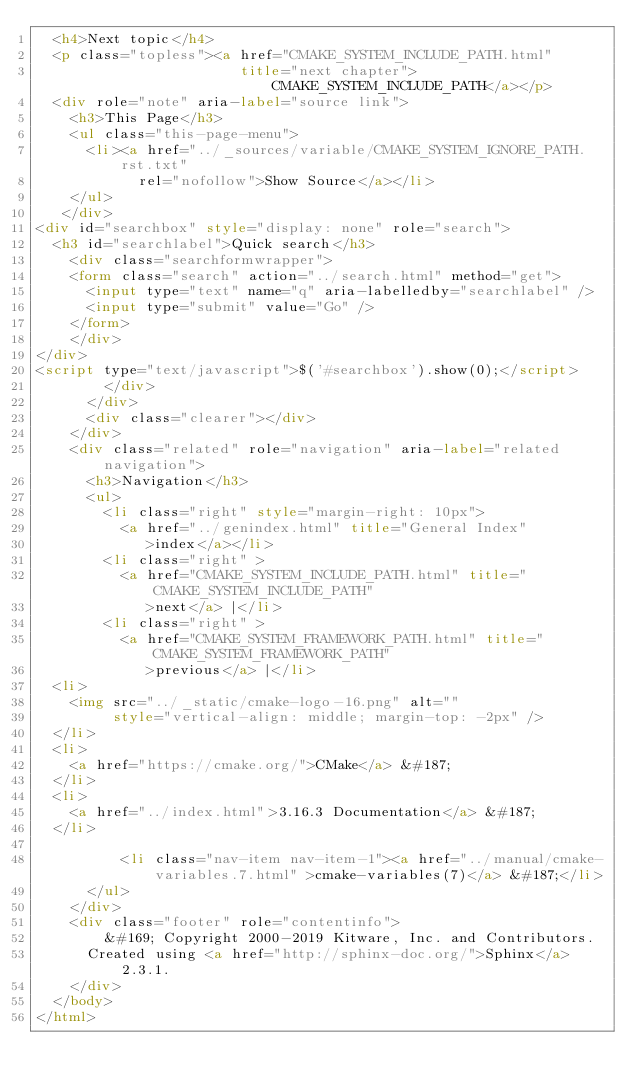<code> <loc_0><loc_0><loc_500><loc_500><_HTML_>  <h4>Next topic</h4>
  <p class="topless"><a href="CMAKE_SYSTEM_INCLUDE_PATH.html"
                        title="next chapter">CMAKE_SYSTEM_INCLUDE_PATH</a></p>
  <div role="note" aria-label="source link">
    <h3>This Page</h3>
    <ul class="this-page-menu">
      <li><a href="../_sources/variable/CMAKE_SYSTEM_IGNORE_PATH.rst.txt"
            rel="nofollow">Show Source</a></li>
    </ul>
   </div>
<div id="searchbox" style="display: none" role="search">
  <h3 id="searchlabel">Quick search</h3>
    <div class="searchformwrapper">
    <form class="search" action="../search.html" method="get">
      <input type="text" name="q" aria-labelledby="searchlabel" />
      <input type="submit" value="Go" />
    </form>
    </div>
</div>
<script type="text/javascript">$('#searchbox').show(0);</script>
        </div>
      </div>
      <div class="clearer"></div>
    </div>
    <div class="related" role="navigation" aria-label="related navigation">
      <h3>Navigation</h3>
      <ul>
        <li class="right" style="margin-right: 10px">
          <a href="../genindex.html" title="General Index"
             >index</a></li>
        <li class="right" >
          <a href="CMAKE_SYSTEM_INCLUDE_PATH.html" title="CMAKE_SYSTEM_INCLUDE_PATH"
             >next</a> |</li>
        <li class="right" >
          <a href="CMAKE_SYSTEM_FRAMEWORK_PATH.html" title="CMAKE_SYSTEM_FRAMEWORK_PATH"
             >previous</a> |</li>
  <li>
    <img src="../_static/cmake-logo-16.png" alt=""
         style="vertical-align: middle; margin-top: -2px" />
  </li>
  <li>
    <a href="https://cmake.org/">CMake</a> &#187;
  </li>
  <li>
    <a href="../index.html">3.16.3 Documentation</a> &#187;
  </li>

          <li class="nav-item nav-item-1"><a href="../manual/cmake-variables.7.html" >cmake-variables(7)</a> &#187;</li> 
      </ul>
    </div>
    <div class="footer" role="contentinfo">
        &#169; Copyright 2000-2019 Kitware, Inc. and Contributors.
      Created using <a href="http://sphinx-doc.org/">Sphinx</a> 2.3.1.
    </div>
  </body>
</html></code> 